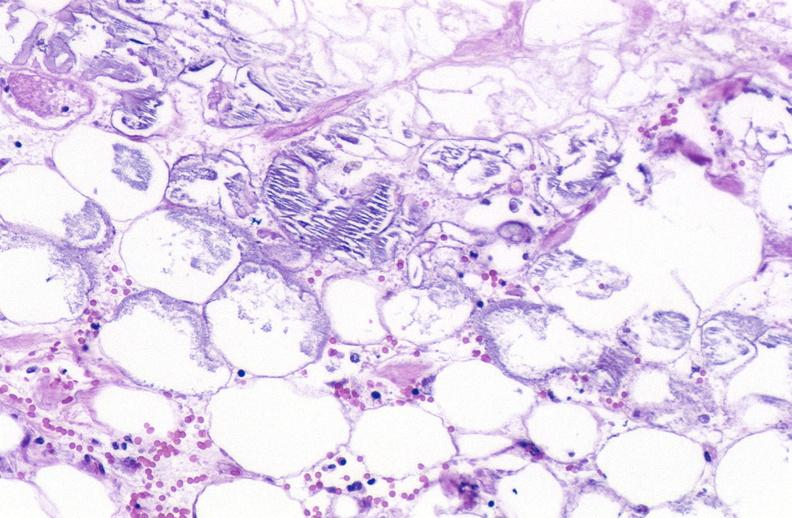does this image show pancreatic fat necrosis?
Answer the question using a single word or phrase. Yes 